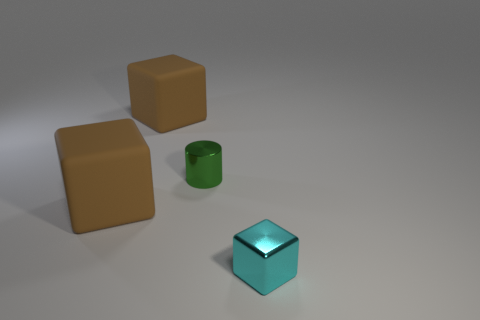Add 1 brown cylinders. How many objects exist? 5 Subtract all cubes. How many objects are left? 1 Subtract 0 green spheres. How many objects are left? 4 Subtract all small green cylinders. Subtract all green matte things. How many objects are left? 3 Add 4 metallic cylinders. How many metallic cylinders are left? 5 Add 2 tiny green shiny cylinders. How many tiny green shiny cylinders exist? 3 